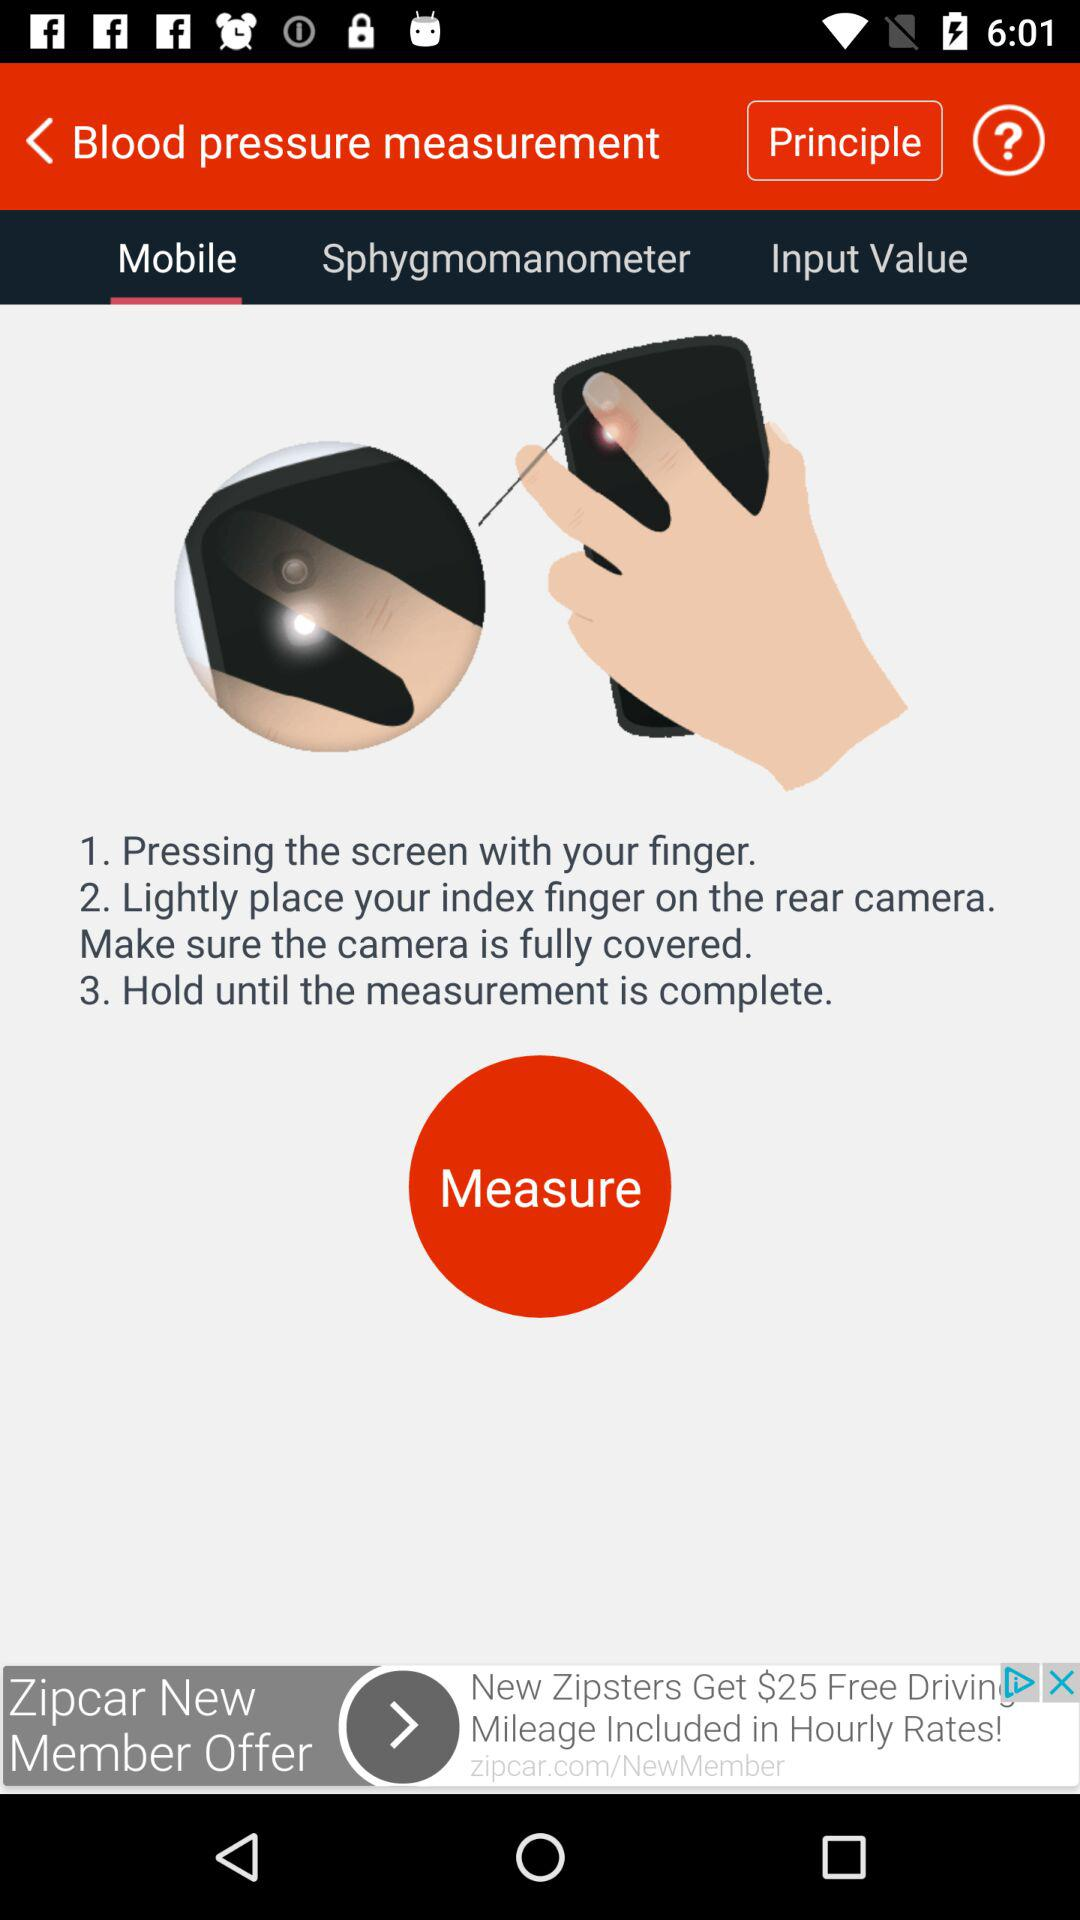What is the application name?
When the provided information is insufficient, respond with <no answer>. <no answer> 